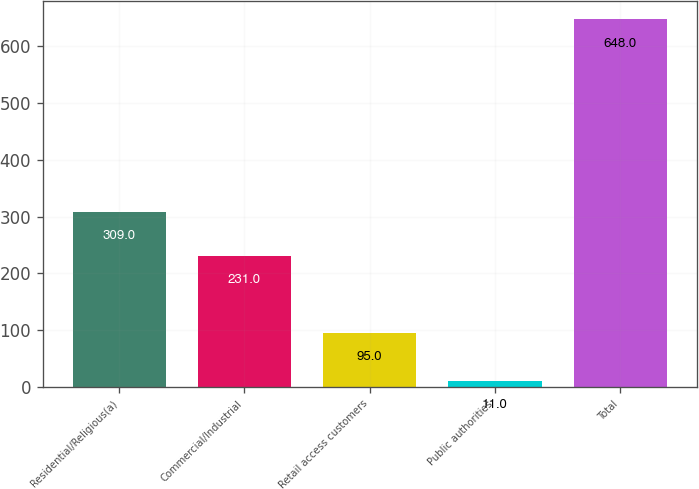<chart> <loc_0><loc_0><loc_500><loc_500><bar_chart><fcel>Residential/Religious(a)<fcel>Commercial/Industrial<fcel>Retail access customers<fcel>Public authorities<fcel>Total<nl><fcel>309<fcel>231<fcel>95<fcel>11<fcel>648<nl></chart> 